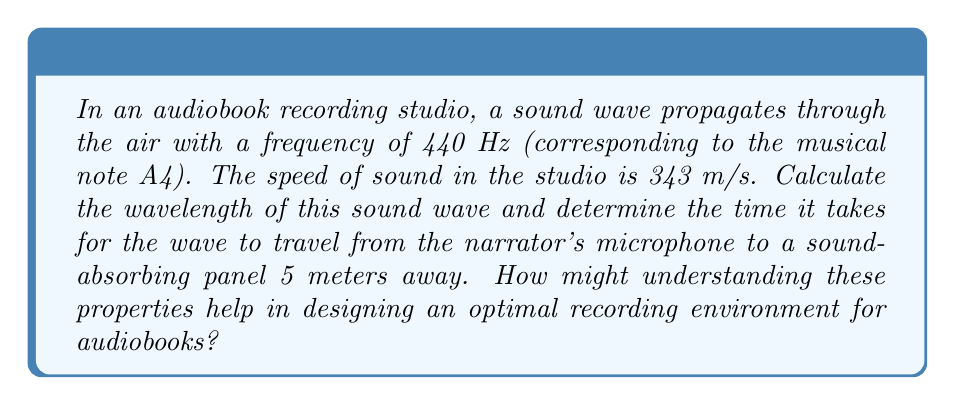Provide a solution to this math problem. Let's approach this problem step-by-step:

1. Calculate the wavelength:
   The wave equation relates frequency (f), wavelength (λ), and wave speed (v):
   
   $$ v = f \lambda $$
   
   Rearranging for wavelength:
   
   $$ \lambda = \frac{v}{f} $$
   
   Substituting the given values:
   
   $$ \lambda = \frac{343 \text{ m/s}}{440 \text{ Hz}} = 0.78 \text{ m} $$

2. Calculate the time for the wave to travel 5 meters:
   Using the equation for speed:
   
   $$ v = \frac{d}{t} $$
   
   Where d is distance and t is time. Rearranging for time:
   
   $$ t = \frac{d}{v} $$
   
   Substituting the values:
   
   $$ t = \frac{5 \text{ m}}{343 \text{ m/s}} = 0.0146 \text{ s} $$

Understanding these properties can help in designing an optimal recording environment for audiobooks in several ways:

1. Wavelength knowledge helps in determining the minimum size of sound-absorbing panels and their placement to effectively dampen reflections.

2. Knowing the time it takes for sound to travel certain distances aids in positioning microphones and sound-absorbing materials to minimize unwanted echoes and reverberations.

3. These calculations can assist in designing the studio's dimensions to avoid standing waves and acoustic nodes, ensuring a more uniform sound quality throughout the space.

4. Understanding wave properties helps in selecting appropriate materials for walls, floors, and ceilings to control sound reflection and absorption, creating a balanced acoustic environment for clear audiobook narration.
Answer: Wavelength: 0.78 m; Travel time: 0.0146 s 